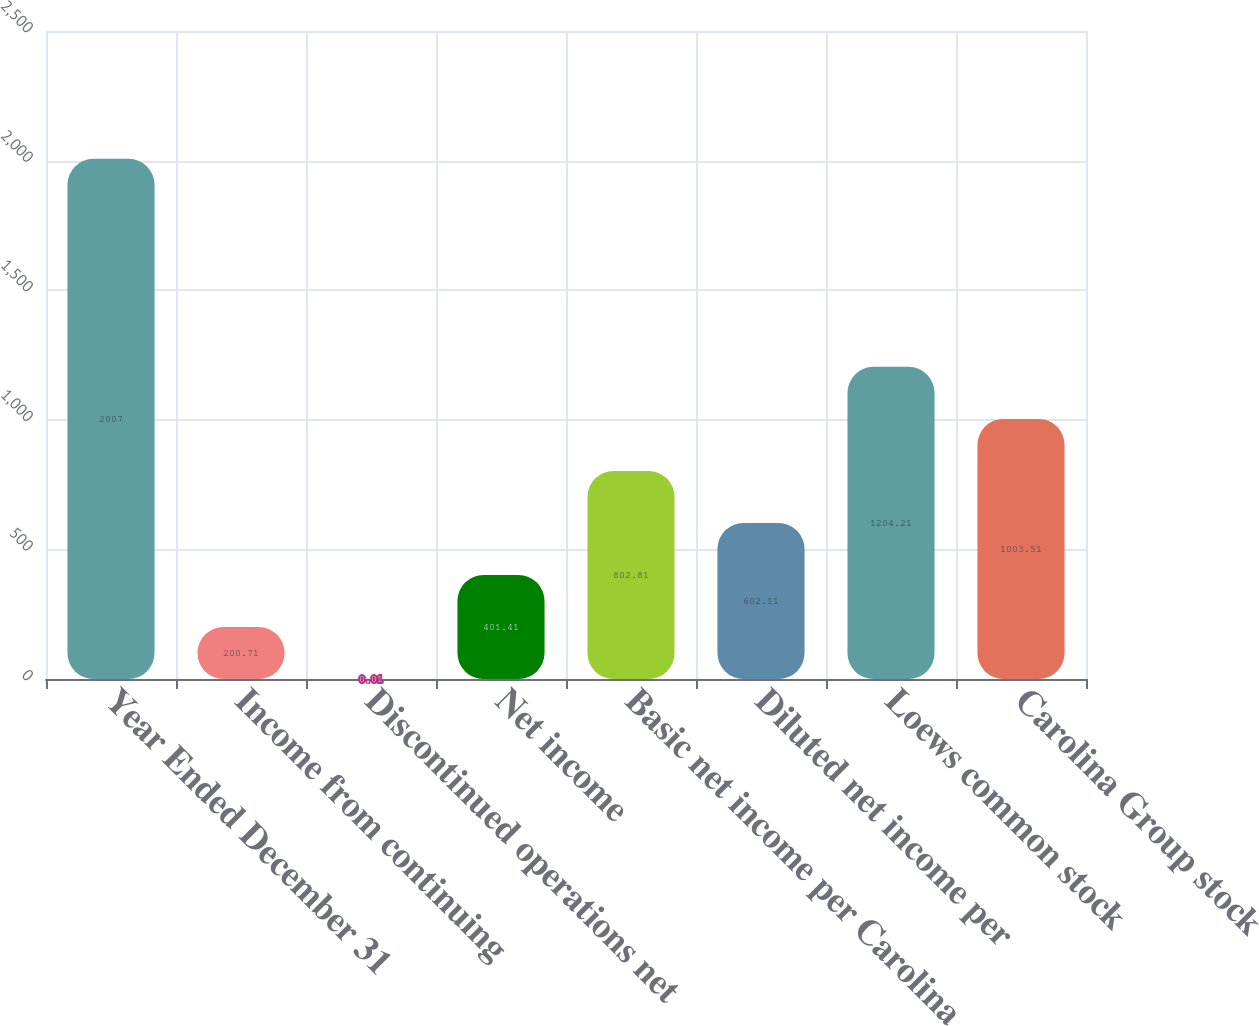Convert chart. <chart><loc_0><loc_0><loc_500><loc_500><bar_chart><fcel>Year Ended December 31<fcel>Income from continuing<fcel>Discontinued operations net<fcel>Net income<fcel>Basic net income per Carolina<fcel>Diluted net income per<fcel>Loews common stock<fcel>Carolina Group stock<nl><fcel>2007<fcel>200.71<fcel>0.01<fcel>401.41<fcel>802.81<fcel>602.11<fcel>1204.21<fcel>1003.51<nl></chart> 